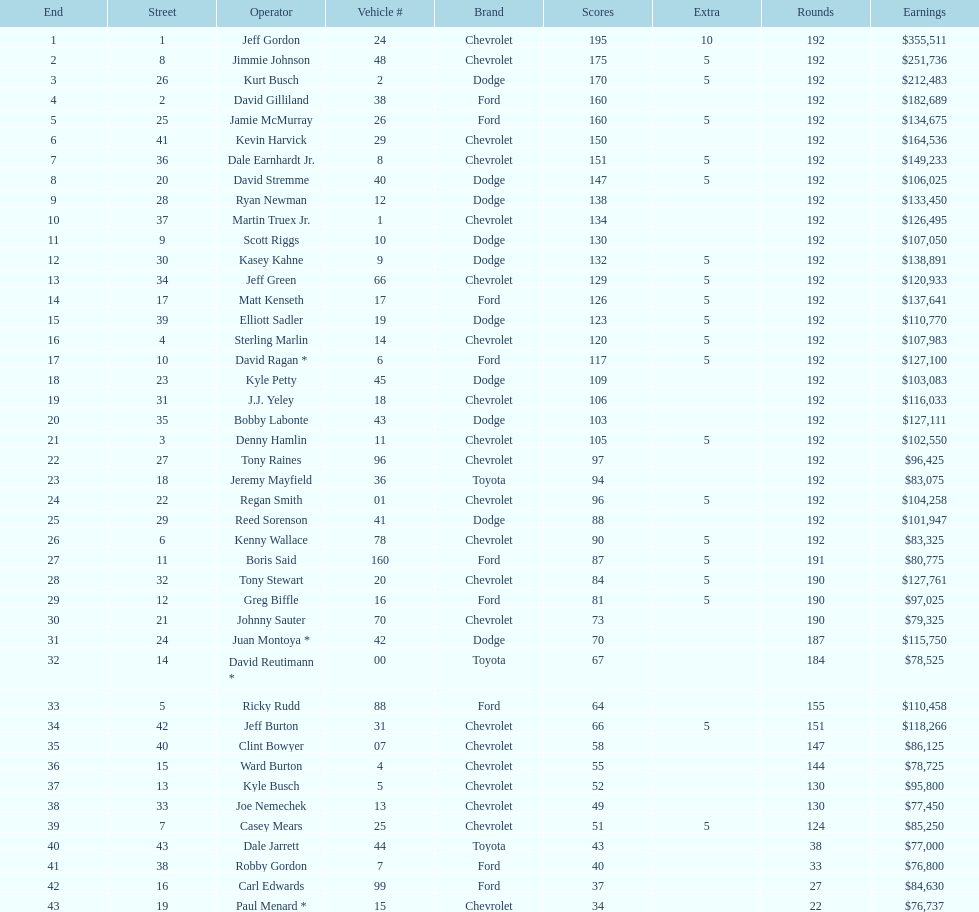Which make had the most consecutive finishes at the aarons 499? Chevrolet. 